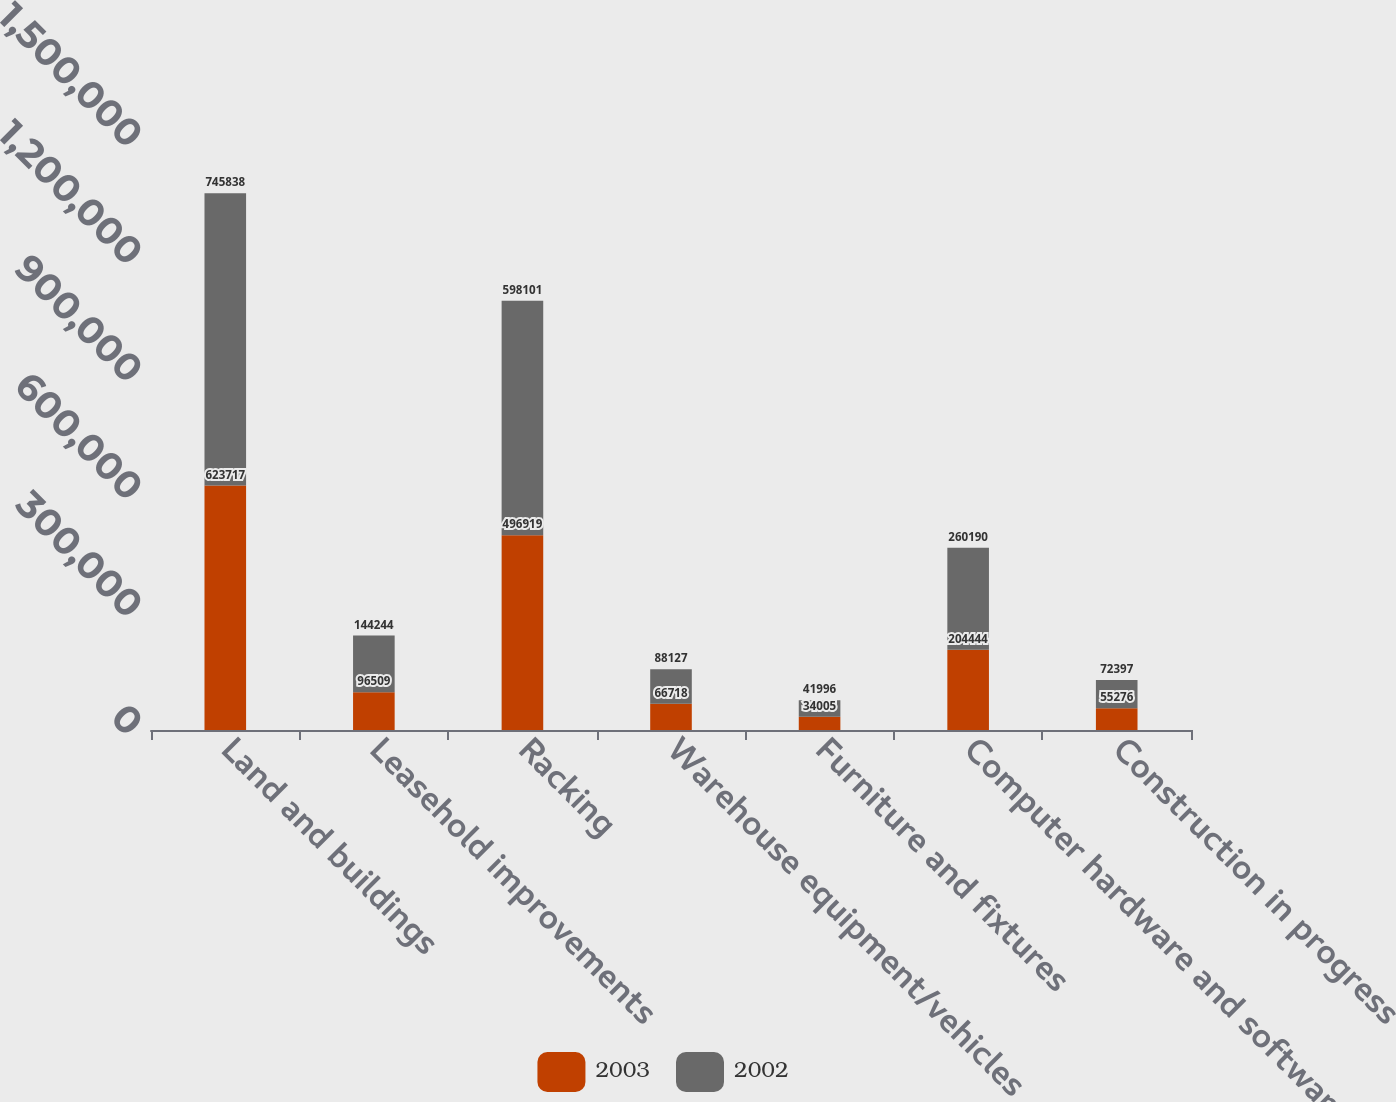Convert chart. <chart><loc_0><loc_0><loc_500><loc_500><stacked_bar_chart><ecel><fcel>Land and buildings<fcel>Leasehold improvements<fcel>Racking<fcel>Warehouse equipment/vehicles<fcel>Furniture and fixtures<fcel>Computer hardware and software<fcel>Construction in progress<nl><fcel>2003<fcel>623717<fcel>96509<fcel>496919<fcel>66718<fcel>34005<fcel>204444<fcel>55276<nl><fcel>2002<fcel>745838<fcel>144244<fcel>598101<fcel>88127<fcel>41996<fcel>260190<fcel>72397<nl></chart> 